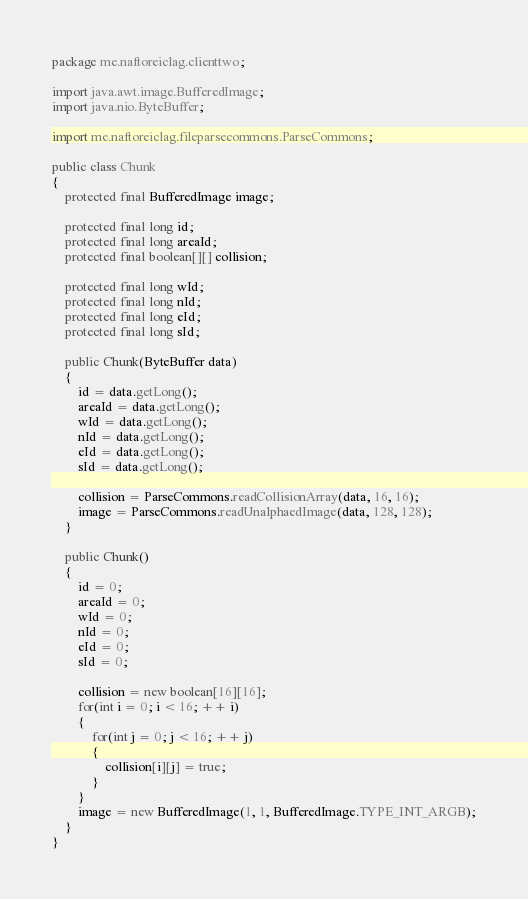Convert code to text. <code><loc_0><loc_0><loc_500><loc_500><_Java_>package me.naftoreiclag.clienttwo;

import java.awt.image.BufferedImage;
import java.nio.ByteBuffer;

import me.naftoreiclag.fileparsecommons.ParseCommons;

public class Chunk
{
	protected final BufferedImage image;
	
	protected final long id;
	protected final long areaId;
	protected final boolean[][] collision;

	protected final long wId;
	protected final long nId;
	protected final long eId;
	protected final long sId;
	
	public Chunk(ByteBuffer data)
	{
		id = data.getLong();
		areaId = data.getLong();
		wId = data.getLong();
		nId = data.getLong();
		eId = data.getLong();
		sId = data.getLong();
		
		collision = ParseCommons.readCollisionArray(data, 16, 16);
		image = ParseCommons.readUnalphaedImage(data, 128, 128);
	}

	public Chunk()
	{
		id = 0;
		areaId = 0;
		wId = 0;
		nId = 0;
		eId = 0;
		sId = 0;
		
		collision = new boolean[16][16];
		for(int i = 0; i < 16; ++ i)
		{
			for(int j = 0; j < 16; ++ j)
			{
				collision[i][j] = true;
			}
		}
		image = new BufferedImage(1, 1, BufferedImage.TYPE_INT_ARGB);
	}
}
</code> 